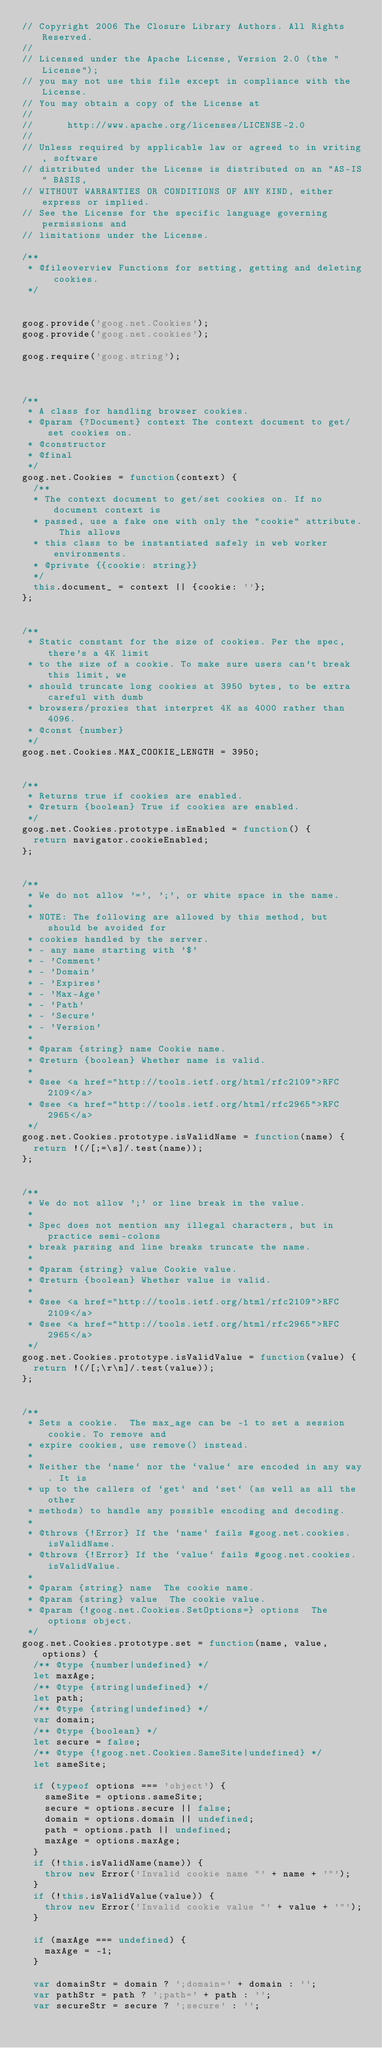<code> <loc_0><loc_0><loc_500><loc_500><_JavaScript_>// Copyright 2006 The Closure Library Authors. All Rights Reserved.
//
// Licensed under the Apache License, Version 2.0 (the "License");
// you may not use this file except in compliance with the License.
// You may obtain a copy of the License at
//
//      http://www.apache.org/licenses/LICENSE-2.0
//
// Unless required by applicable law or agreed to in writing, software
// distributed under the License is distributed on an "AS-IS" BASIS,
// WITHOUT WARRANTIES OR CONDITIONS OF ANY KIND, either express or implied.
// See the License for the specific language governing permissions and
// limitations under the License.

/**
 * @fileoverview Functions for setting, getting and deleting cookies.
 */


goog.provide('goog.net.Cookies');
goog.provide('goog.net.cookies');

goog.require('goog.string');



/**
 * A class for handling browser cookies.
 * @param {?Document} context The context document to get/set cookies on.
 * @constructor
 * @final
 */
goog.net.Cookies = function(context) {
  /**
  * The context document to get/set cookies on. If no document context is
  * passed, use a fake one with only the "cookie" attribute. This allows
  * this class to be instantiated safely in web worker environments.
  * @private {{cookie: string}}
  */
  this.document_ = context || {cookie: ''};
};


/**
 * Static constant for the size of cookies. Per the spec, there's a 4K limit
 * to the size of a cookie. To make sure users can't break this limit, we
 * should truncate long cookies at 3950 bytes, to be extra careful with dumb
 * browsers/proxies that interpret 4K as 4000 rather than 4096.
 * @const {number}
 */
goog.net.Cookies.MAX_COOKIE_LENGTH = 3950;


/**
 * Returns true if cookies are enabled.
 * @return {boolean} True if cookies are enabled.
 */
goog.net.Cookies.prototype.isEnabled = function() {
  return navigator.cookieEnabled;
};


/**
 * We do not allow '=', ';', or white space in the name.
 *
 * NOTE: The following are allowed by this method, but should be avoided for
 * cookies handled by the server.
 * - any name starting with '$'
 * - 'Comment'
 * - 'Domain'
 * - 'Expires'
 * - 'Max-Age'
 * - 'Path'
 * - 'Secure'
 * - 'Version'
 *
 * @param {string} name Cookie name.
 * @return {boolean} Whether name is valid.
 *
 * @see <a href="http://tools.ietf.org/html/rfc2109">RFC 2109</a>
 * @see <a href="http://tools.ietf.org/html/rfc2965">RFC 2965</a>
 */
goog.net.Cookies.prototype.isValidName = function(name) {
  return !(/[;=\s]/.test(name));
};


/**
 * We do not allow ';' or line break in the value.
 *
 * Spec does not mention any illegal characters, but in practice semi-colons
 * break parsing and line breaks truncate the name.
 *
 * @param {string} value Cookie value.
 * @return {boolean} Whether value is valid.
 *
 * @see <a href="http://tools.ietf.org/html/rfc2109">RFC 2109</a>
 * @see <a href="http://tools.ietf.org/html/rfc2965">RFC 2965</a>
 */
goog.net.Cookies.prototype.isValidValue = function(value) {
  return !(/[;\r\n]/.test(value));
};


/**
 * Sets a cookie.  The max_age can be -1 to set a session cookie. To remove and
 * expire cookies, use remove() instead.
 *
 * Neither the `name` nor the `value` are encoded in any way. It is
 * up to the callers of `get` and `set` (as well as all the other
 * methods) to handle any possible encoding and decoding.
 *
 * @throws {!Error} If the `name` fails #goog.net.cookies.isValidName.
 * @throws {!Error} If the `value` fails #goog.net.cookies.isValidValue.
 *
 * @param {string} name  The cookie name.
 * @param {string} value  The cookie value.
 * @param {!goog.net.Cookies.SetOptions=} options  The options object.
 */
goog.net.Cookies.prototype.set = function(name, value, options) {
  /** @type {number|undefined} */
  let maxAge;
  /** @type {string|undefined} */
  let path;
  /** @type {string|undefined} */
  var domain;
  /** @type {boolean} */
  let secure = false;
  /** @type {!goog.net.Cookies.SameSite|undefined} */
  let sameSite;

  if (typeof options === 'object') {
    sameSite = options.sameSite;
    secure = options.secure || false;
    domain = options.domain || undefined;
    path = options.path || undefined;
    maxAge = options.maxAge;
  }
  if (!this.isValidName(name)) {
    throw new Error('Invalid cookie name "' + name + '"');
  }
  if (!this.isValidValue(value)) {
    throw new Error('Invalid cookie value "' + value + '"');
  }

  if (maxAge === undefined) {
    maxAge = -1;
  }

  var domainStr = domain ? ';domain=' + domain : '';
  var pathStr = path ? ';path=' + path : '';
  var secureStr = secure ? ';secure' : '';
</code> 